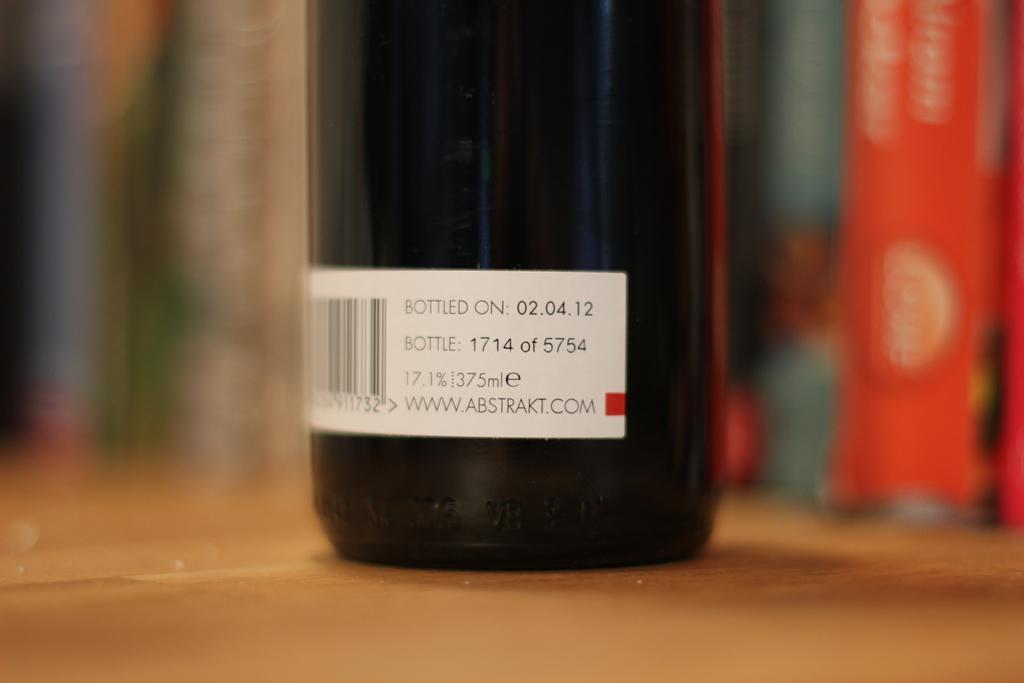In one or two sentences, can you explain what this image depicts? In this picture there is a bottle on the table and there is a sticker on the bottle. At the back there are books and the image is blurry. 